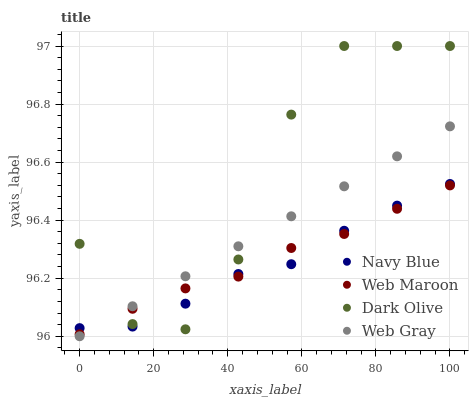Does Navy Blue have the minimum area under the curve?
Answer yes or no. Yes. Does Dark Olive have the maximum area under the curve?
Answer yes or no. Yes. Does Dark Olive have the minimum area under the curve?
Answer yes or no. No. Does Navy Blue have the maximum area under the curve?
Answer yes or no. No. Is Web Gray the smoothest?
Answer yes or no. Yes. Is Dark Olive the roughest?
Answer yes or no. Yes. Is Navy Blue the smoothest?
Answer yes or no. No. Is Navy Blue the roughest?
Answer yes or no. No. Does Web Gray have the lowest value?
Answer yes or no. Yes. Does Dark Olive have the lowest value?
Answer yes or no. No. Does Dark Olive have the highest value?
Answer yes or no. Yes. Does Navy Blue have the highest value?
Answer yes or no. No. Does Web Gray intersect Web Maroon?
Answer yes or no. Yes. Is Web Gray less than Web Maroon?
Answer yes or no. No. Is Web Gray greater than Web Maroon?
Answer yes or no. No. 